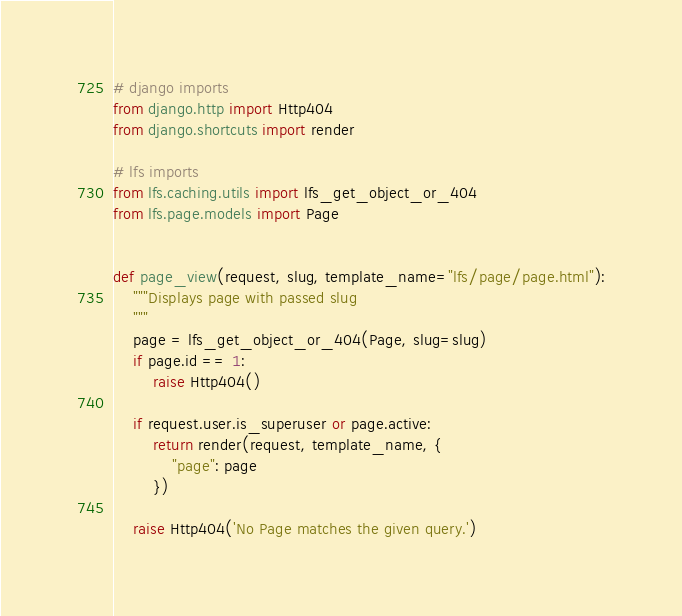Convert code to text. <code><loc_0><loc_0><loc_500><loc_500><_Python_># django imports
from django.http import Http404
from django.shortcuts import render

# lfs imports
from lfs.caching.utils import lfs_get_object_or_404
from lfs.page.models import Page


def page_view(request, slug, template_name="lfs/page/page.html"):
    """Displays page with passed slug
    """
    page = lfs_get_object_or_404(Page, slug=slug)
    if page.id == 1:
        raise Http404()

    if request.user.is_superuser or page.active:
        return render(request, template_name, {
            "page": page
        })

    raise Http404('No Page matches the given query.')

</code> 